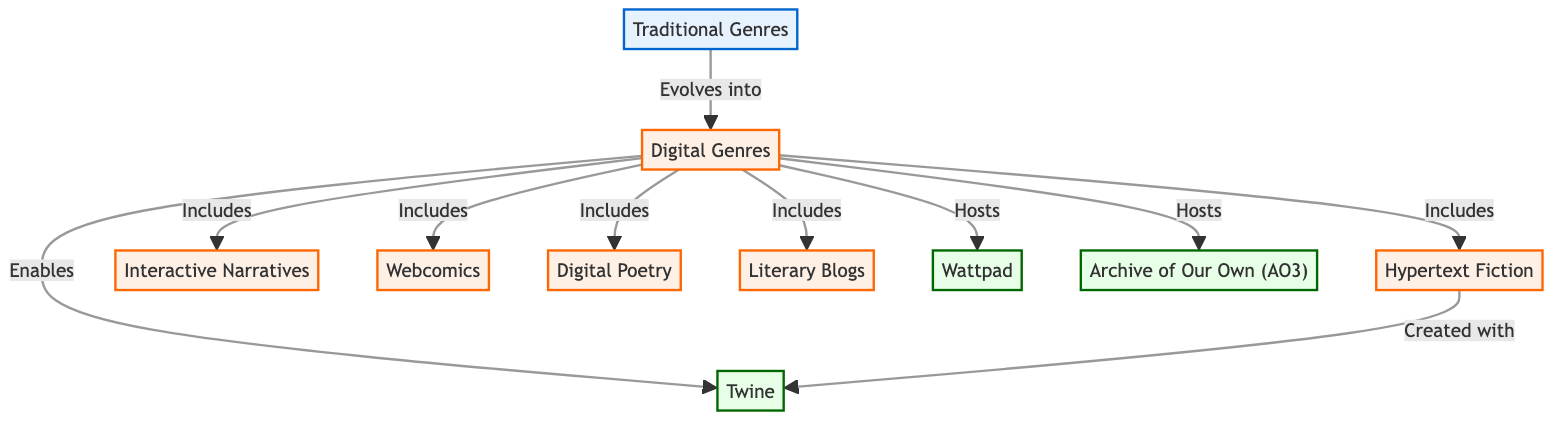What are the established genres in literature before the digital era? The diagram identifies "Traditional Genres" as the node that represents established genres in literature pre-digital era, such as poetry, drama, and novels.
Answer: Traditional Genres How many types of digital genres are included in the diagram? The diagram shows a single node labeled "Digital Genres," which connects to six different types of digital genres, indicating there are six types included.
Answer: 6 Which digital genre allows for reader interaction that alters the narrative? The node "Interactive Narratives" in the diagram specifically states that it allows for reader interaction that changes the storyline based on the reader's choices.
Answer: Interactive Narratives What does "Digital Genres" evolve from? The connection in the diagram shows that "Digital Genres" evolves from "Traditional Genres," indicating that those pre-digital forms of literature influenced the development of digital ones.
Answer: Traditional Genres Which platform is specifically mentioned as hosting fan fiction? The node "Archive of Our Own (AO3)" is clearly labeled as a platform that hosts fan fiction and other transformative works, as indicated in the diagram.
Answer: Archive of Our Own (AO3) What genre is created with the tool Twine? The diagram illustrates a connection from the node "Hypertext Fiction" to "Twine," stating "Created with," highlighting that hypertext fiction is created using this specific tool.
Answer: Hypertext Fiction Which digital genre utilizes dynamic presentations and multimedia content? The node "Digital Poetry" in the diagram describes poetry that utilizes the digital medium for dynamic presentations, interactive elements, or multimedia content.
Answer: Digital Poetry What do the digital genres included share with "Wattpad"? The term "Hosts" is used to describe the relationship between "Digital Genres" and "Wattpad," indicating that Wattpad serves as a platform for the digital genres to be shared and explored.
Answer: Hosts What is the primary function of Twine in digital literature? In the diagram, Twine is noted as enabling digital genres, specifically allowing for the creation of interactive, nonlinear stories which enhances the experience of digital literature.
Answer: Enables How many total connections are made from the "Digital Genres" node? The diagram shows that the "Digital Genres" node connects to eight other nodes (including itself), denoting its importance in the network.
Answer: 8 